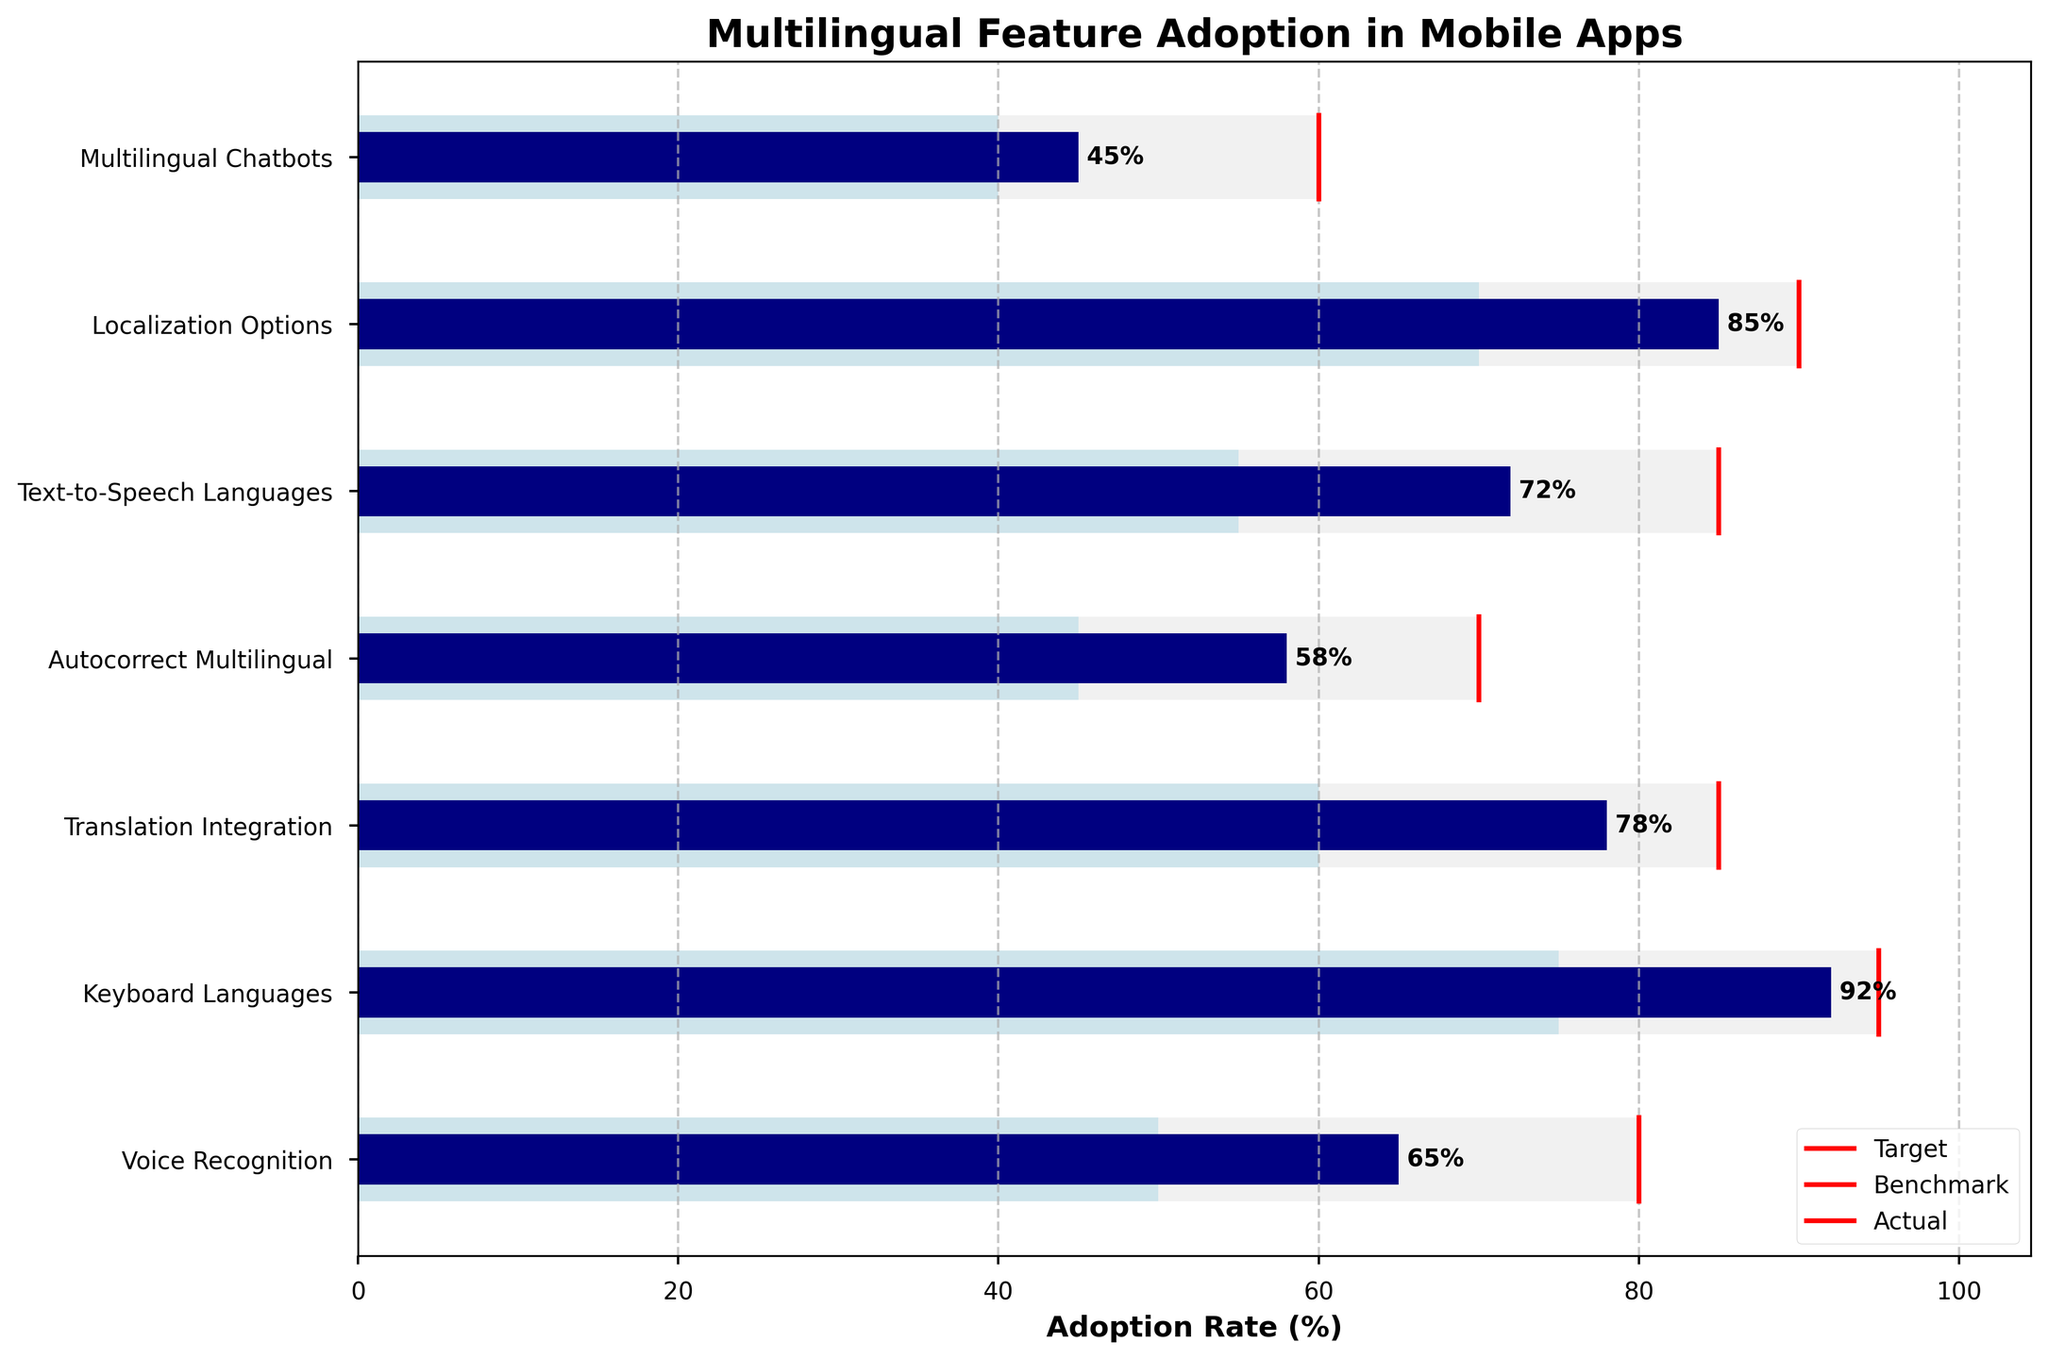How many features are evaluated in the Bullet Chart? Count the number of different features listed on the y-axis. There are seven different features listed.
Answer: Seven Which feature has the highest actual adoption rate? Identify the bar with the highest value on the x-axis. The longest navy bar corresponds to "Keyboard Languages," which has an actual adoption rate of 92%.
Answer: Keyboard Languages How does the actual adoption rate of "Translation Integration" compare to its benchmark? Compare the heights of the navy bar (Actual) and the light blue bar (Benchmark) for "Translation Integration." The actual adoption rate is 78%, and the benchmark is 60%.
Answer: Higher What is the difference between the target and actual adoption rates for "Voice Recognition"? Subtract the actual rate from the target rate for "Voice Recognition." The target is 80%, and the actual rate is 65%, so the difference is 15%.
Answer: 15% Which feature shows the smallest gap between the actual adoption rate and the target? Calculate the difference between the target and actual rates for all features, and identify the smallest gap. "Keyboard Languages" has the smallest gap with a target of 95% and an actual rate of 92%, a difference of 3%.
Answer: Keyboard Languages Does the "Autocorrect Multilingual" feature meet its benchmark? Compare the actual rate with the benchmark for "Autocorrect Multilingual." The actual rate is 58%, and the benchmark is 45%. Since 58% is greater than 45%, it meets and exceeds the benchmark.
Answer: Yes In how many features does the actual adoption rate exceed the benchmark adoption rate? Compare the actual and benchmark rates for each feature and count how many times the actual rate is higher. For "Voice Recognition," "Keyboard Languages," "Translation Integration," "Autocorrect Multilingual," "Text-to-Speech Languages," and "Localization Options," the actual rates exceed the benchmarks. There are six such features.
Answer: Six Which feature has the largest gap between the actual adoption rate and the benchmark? Calculate the difference between the actual and benchmark rates for all features and identify the largest gap. For "Text-to-Speech Languages," the actual rate is 72% and the benchmark is 55%, a difference of 17%.
Answer: Text-to-Speech Languages 